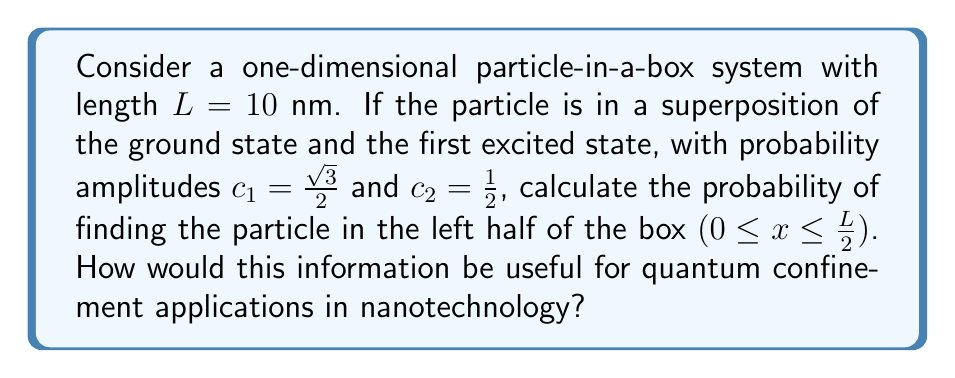Provide a solution to this math problem. To solve this problem, we'll follow these steps:

1) The wavefunctions for the ground state $(n=1)$ and first excited state $(n=2)$ are:

   $\psi_1(x) = \sqrt{\frac{2}{L}} \sin(\frac{\pi x}{L})$
   $\psi_2(x) = \sqrt{\frac{2}{L}} \sin(\frac{2\pi x}{L})$

2) The superposition state is:

   $\Psi(x) = c_1\psi_1(x) + c_2\psi_2(x)$

3) The probability density is:

   $|\Psi(x)|^2 = |c_1\psi_1(x) + c_2\psi_2(x)|^2$

4) Expanding this:

   $|\Psi(x)|^2 = |c_1|^2|\psi_1(x)|^2 + |c_2|^2|\psi_2(x)|^2 + 2\text{Re}(c_1^*c_2\psi_1^*(x)\psi_2(x))$

5) Substituting the values and simplifying:

   $|\Psi(x)|^2 = \frac{2}{L}[\frac{3}{4}\sin^2(\frac{\pi x}{L}) + \frac{1}{4}\sin^2(\frac{2\pi x}{L}) + \frac{\sqrt{3}}{2}\sin(\frac{\pi x}{L})\sin(\frac{2\pi x}{L})]$

6) To find the probability in the left half, we integrate from 0 to L/2:

   $P = \int_0^{L/2} |\Psi(x)|^2 dx$

7) Solving this integral (which involves trigonometric integrals) gives:

   $P = \frac{1}{2} + \frac{\sqrt{3}}{2\pi} \approx 0.7746$

This result shows that the particle has a higher probability of being found in the left half of the box, which is due to the interference between the ground state and first excited state.

For nanotechnology applications, understanding such probability distributions is crucial for designing quantum wells, quantum dots, and other nanostructures where quantum confinement effects are significant. It allows for precise control of electron localization, which is essential for developing efficient quantum devices, sensors, and advanced electronic components.
Answer: $P = \frac{1}{2} + \frac{\sqrt{3}}{2\pi} \approx 0.7746$ 